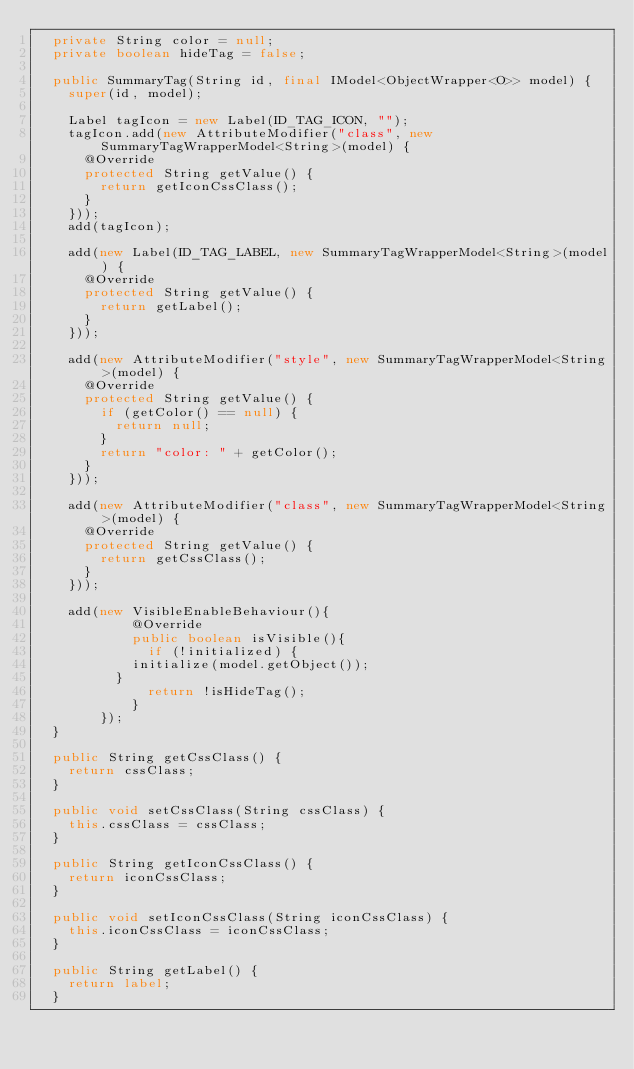<code> <loc_0><loc_0><loc_500><loc_500><_Java_>	private String color = null;
	private boolean hideTag = false;
	
	public SummaryTag(String id, final IModel<ObjectWrapper<O>> model) {
		super(id, model);
		
		Label tagIcon = new Label(ID_TAG_ICON, "");
		tagIcon.add(new AttributeModifier("class", new SummaryTagWrapperModel<String>(model) {
			@Override
			protected String getValue() {
				return getIconCssClass();
			}
		}));
		add(tagIcon);
		
		add(new Label(ID_TAG_LABEL, new SummaryTagWrapperModel<String>(model) {
			@Override
			protected String getValue() {
				return getLabel();
			}
		}));
		
		add(new AttributeModifier("style", new SummaryTagWrapperModel<String>(model) {
			@Override
			protected String getValue() {
				if (getColor() == null) {
					return null;
				}
				return "color: " + getColor();
			}
		}));
		
		add(new AttributeModifier("class", new SummaryTagWrapperModel<String>(model) {
			@Override
			protected String getValue() {
				return getCssClass();
			}
		}));
		
		add(new VisibleEnableBehaviour(){    		
            @Override
            public boolean isVisible(){
            	if (!initialized) {
    				initialize(model.getObject());
    			}
            	return !isHideTag();
            }
        });
	}
	
	public String getCssClass() {
		return cssClass;
	}

	public void setCssClass(String cssClass) {
		this.cssClass = cssClass;
	}

	public String getIconCssClass() {
		return iconCssClass;
	}

	public void setIconCssClass(String iconCssClass) {
		this.iconCssClass = iconCssClass;
	}
	
	public String getLabel() {
		return label;
	}
</code> 